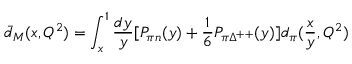<formula> <loc_0><loc_0><loc_500><loc_500>\bar { d } _ { M } ( x , Q ^ { 2 } ) = \int _ { x } ^ { 1 } \frac { d y } { y } [ P _ { \pi n } ( y ) + \frac { 1 } { 6 } P _ { \pi \Delta ^ { + + } } ( y ) ] d _ { \pi } ( \frac { x } { y } , Q ^ { 2 } )</formula> 